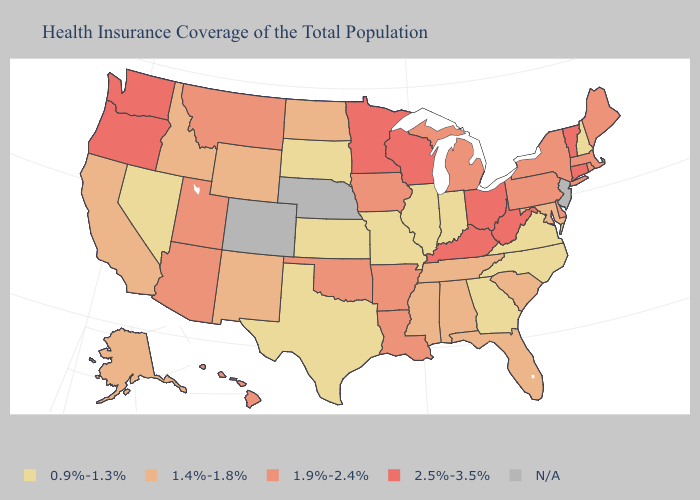What is the lowest value in the USA?
Write a very short answer. 0.9%-1.3%. Does the map have missing data?
Quick response, please. Yes. Name the states that have a value in the range 2.5%-3.5%?
Give a very brief answer. Connecticut, Kentucky, Minnesota, Ohio, Oregon, Vermont, Washington, West Virginia, Wisconsin. What is the highest value in the West ?
Quick response, please. 2.5%-3.5%. What is the lowest value in the USA?
Give a very brief answer. 0.9%-1.3%. Name the states that have a value in the range 0.9%-1.3%?
Write a very short answer. Georgia, Illinois, Indiana, Kansas, Missouri, Nevada, New Hampshire, North Carolina, South Dakota, Texas, Virginia. What is the lowest value in the USA?
Be succinct. 0.9%-1.3%. Does New Mexico have the highest value in the USA?
Keep it brief. No. What is the lowest value in the West?
Give a very brief answer. 0.9%-1.3%. Name the states that have a value in the range 1.4%-1.8%?
Short answer required. Alabama, Alaska, California, Florida, Idaho, Maryland, Mississippi, New Mexico, North Dakota, South Carolina, Tennessee, Wyoming. What is the value of Oregon?
Quick response, please. 2.5%-3.5%. What is the highest value in states that border South Carolina?
Short answer required. 0.9%-1.3%. 